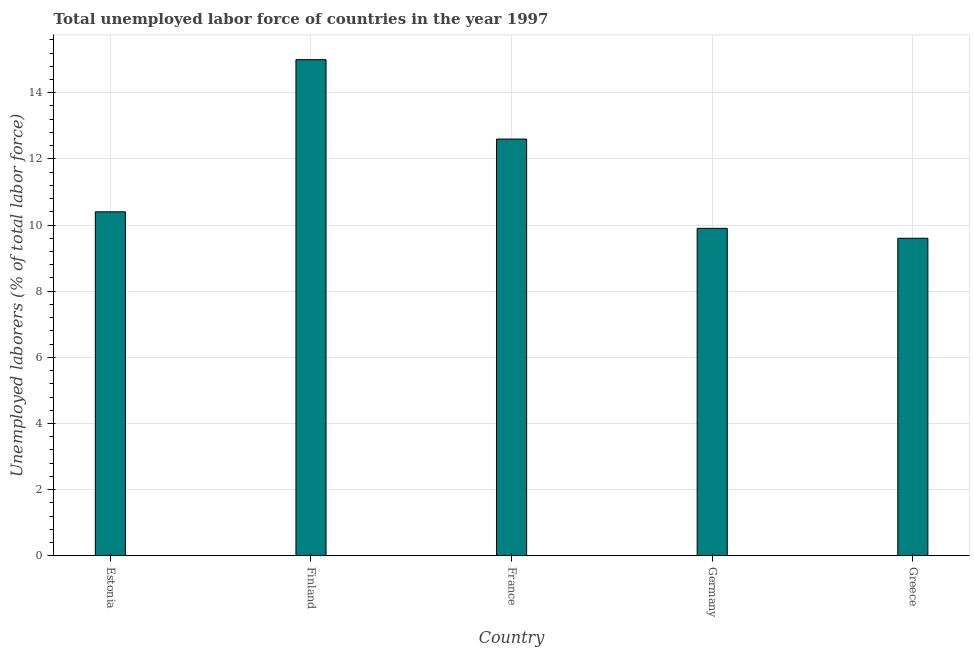What is the title of the graph?
Provide a short and direct response. Total unemployed labor force of countries in the year 1997. What is the label or title of the Y-axis?
Provide a short and direct response. Unemployed laborers (% of total labor force). What is the total unemployed labour force in Estonia?
Your answer should be compact. 10.4. Across all countries, what is the maximum total unemployed labour force?
Your response must be concise. 15. Across all countries, what is the minimum total unemployed labour force?
Provide a short and direct response. 9.6. In which country was the total unemployed labour force maximum?
Offer a terse response. Finland. What is the sum of the total unemployed labour force?
Your answer should be very brief. 57.5. What is the difference between the total unemployed labour force in France and Germany?
Keep it short and to the point. 2.7. What is the average total unemployed labour force per country?
Ensure brevity in your answer.  11.5. What is the median total unemployed labour force?
Your response must be concise. 10.4. In how many countries, is the total unemployed labour force greater than 7.2 %?
Make the answer very short. 5. What is the ratio of the total unemployed labour force in France to that in Germany?
Provide a short and direct response. 1.27. Is the difference between the total unemployed labour force in Finland and France greater than the difference between any two countries?
Keep it short and to the point. No. What is the difference between the highest and the second highest total unemployed labour force?
Your response must be concise. 2.4. Is the sum of the total unemployed labour force in Finland and France greater than the maximum total unemployed labour force across all countries?
Provide a succinct answer. Yes. How many countries are there in the graph?
Your answer should be very brief. 5. What is the difference between two consecutive major ticks on the Y-axis?
Keep it short and to the point. 2. Are the values on the major ticks of Y-axis written in scientific E-notation?
Your response must be concise. No. What is the Unemployed laborers (% of total labor force) in Estonia?
Provide a succinct answer. 10.4. What is the Unemployed laborers (% of total labor force) of France?
Make the answer very short. 12.6. What is the Unemployed laborers (% of total labor force) of Germany?
Ensure brevity in your answer.  9.9. What is the Unemployed laborers (% of total labor force) in Greece?
Make the answer very short. 9.6. What is the difference between the Unemployed laborers (% of total labor force) in Estonia and Finland?
Offer a terse response. -4.6. What is the difference between the Unemployed laborers (% of total labor force) in Estonia and France?
Keep it short and to the point. -2.2. What is the difference between the Unemployed laborers (% of total labor force) in Estonia and Greece?
Make the answer very short. 0.8. What is the difference between the Unemployed laborers (% of total labor force) in Finland and France?
Your answer should be very brief. 2.4. What is the difference between the Unemployed laborers (% of total labor force) in Germany and Greece?
Your answer should be very brief. 0.3. What is the ratio of the Unemployed laborers (% of total labor force) in Estonia to that in Finland?
Offer a very short reply. 0.69. What is the ratio of the Unemployed laborers (% of total labor force) in Estonia to that in France?
Make the answer very short. 0.82. What is the ratio of the Unemployed laborers (% of total labor force) in Estonia to that in Germany?
Offer a terse response. 1.05. What is the ratio of the Unemployed laborers (% of total labor force) in Estonia to that in Greece?
Offer a terse response. 1.08. What is the ratio of the Unemployed laborers (% of total labor force) in Finland to that in France?
Give a very brief answer. 1.19. What is the ratio of the Unemployed laborers (% of total labor force) in Finland to that in Germany?
Your response must be concise. 1.51. What is the ratio of the Unemployed laborers (% of total labor force) in Finland to that in Greece?
Offer a very short reply. 1.56. What is the ratio of the Unemployed laborers (% of total labor force) in France to that in Germany?
Offer a terse response. 1.27. What is the ratio of the Unemployed laborers (% of total labor force) in France to that in Greece?
Provide a short and direct response. 1.31. What is the ratio of the Unemployed laborers (% of total labor force) in Germany to that in Greece?
Give a very brief answer. 1.03. 